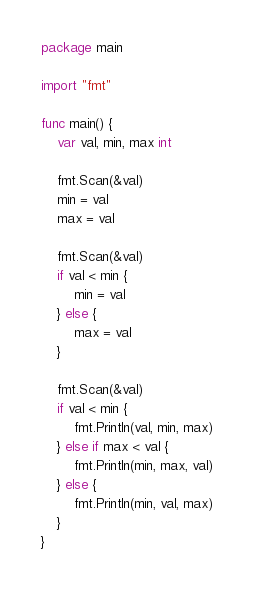<code> <loc_0><loc_0><loc_500><loc_500><_Go_>package main

import "fmt"

func main() {
	var val, min, max int

	fmt.Scan(&val)
	min = val
	max = val

	fmt.Scan(&val)
	if val < min {
		min = val
	} else {
		max = val
	}

	fmt.Scan(&val)
	if val < min {
		fmt.Println(val, min, max)
	} else if max < val {
		fmt.Println(min, max, val)
	} else {
		fmt.Println(min, val, max)
	}
}

</code> 